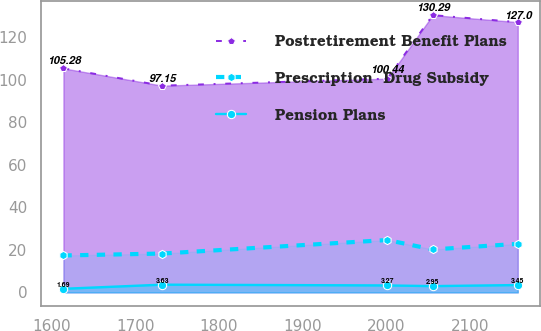<chart> <loc_0><loc_0><loc_500><loc_500><line_chart><ecel><fcel>Postretirement Benefit Plans<fcel>Prescription  Drug Subsidy<fcel>Pension Plans<nl><fcel>1614.33<fcel>105.28<fcel>17.35<fcel>1.69<nl><fcel>1732.14<fcel>97.15<fcel>18.25<fcel>3.63<nl><fcel>2001.33<fcel>100.44<fcel>24.61<fcel>3.27<nl><fcel>2055.62<fcel>130.29<fcel>20.17<fcel>2.95<nl><fcel>2157.2<fcel>127<fcel>22.82<fcel>3.45<nl></chart> 